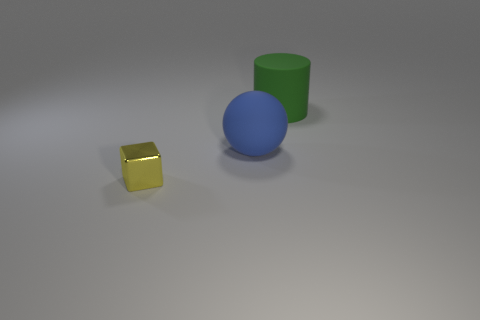Add 3 blue matte objects. How many objects exist? 6 Subtract all blocks. How many objects are left? 2 Subtract 0 gray balls. How many objects are left? 3 Subtract all large green matte objects. Subtract all tiny purple cylinders. How many objects are left? 2 Add 1 cylinders. How many cylinders are left? 2 Add 1 small cyan matte balls. How many small cyan matte balls exist? 1 